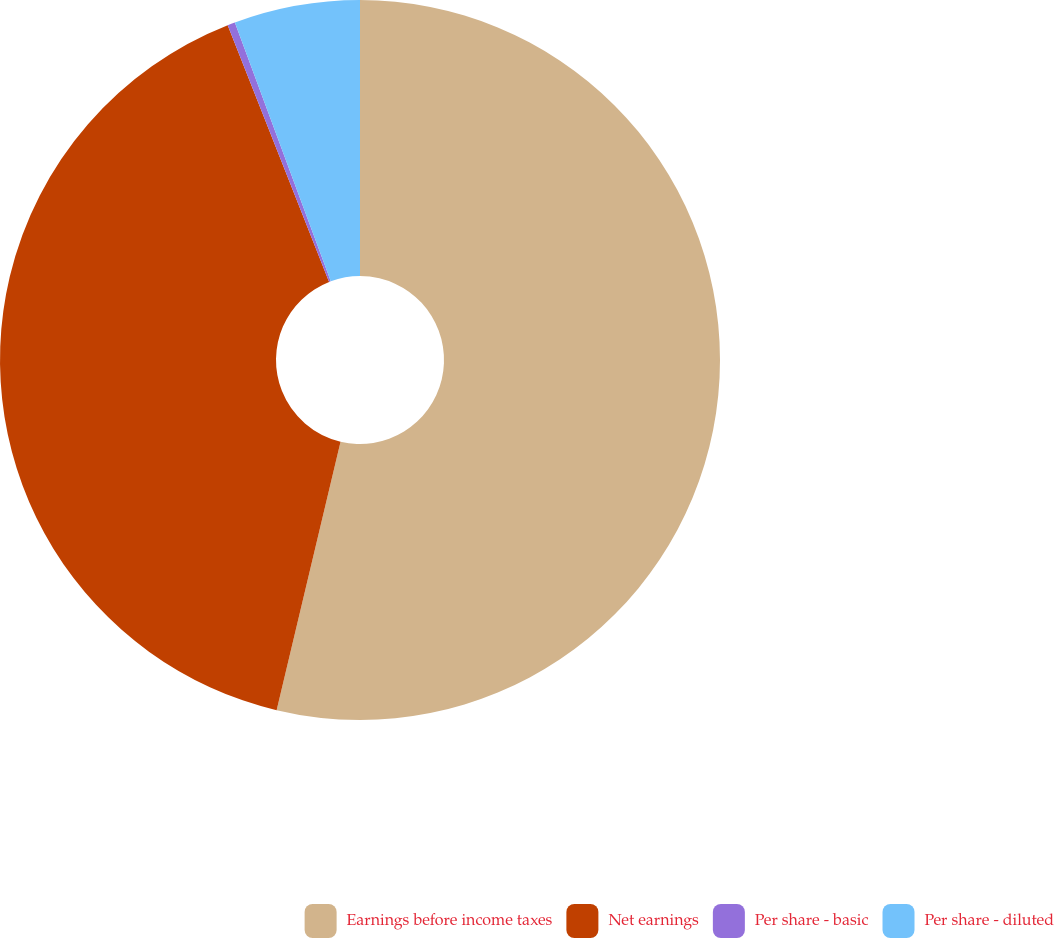<chart> <loc_0><loc_0><loc_500><loc_500><pie_chart><fcel>Earnings before income taxes<fcel>Net earnings<fcel>Per share - basic<fcel>Per share - diluted<nl><fcel>53.72%<fcel>40.29%<fcel>0.34%<fcel>5.65%<nl></chart> 